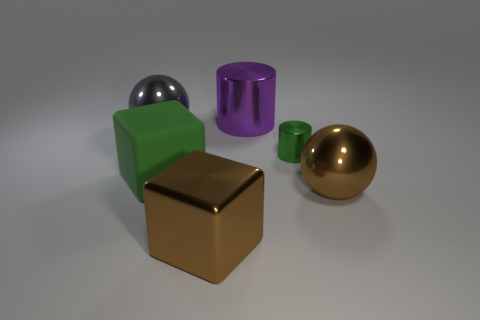Add 1 tiny cylinders. How many objects exist? 7 Subtract all cylinders. How many objects are left? 4 Subtract all small green metallic objects. Subtract all large metal cylinders. How many objects are left? 4 Add 1 small metal cylinders. How many small metal cylinders are left? 2 Add 1 gray things. How many gray things exist? 2 Subtract 0 yellow cylinders. How many objects are left? 6 